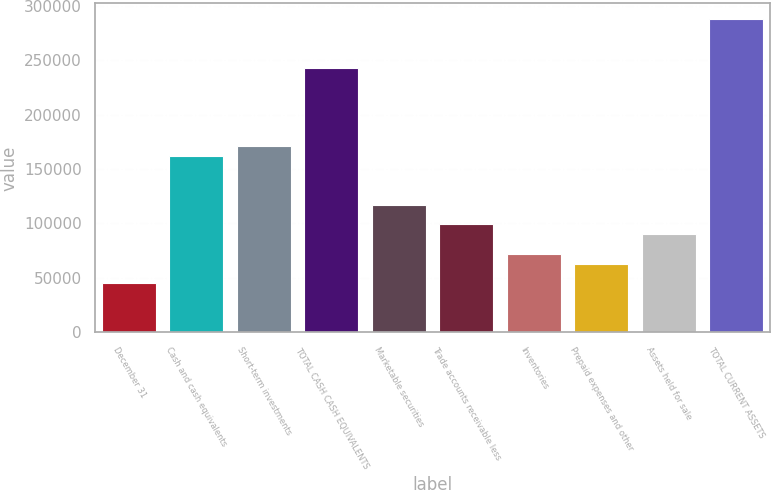<chart> <loc_0><loc_0><loc_500><loc_500><bar_chart><fcel>December 31<fcel>Cash and cash equivalents<fcel>Short-term investments<fcel>TOTAL CASH CASH EQUIVALENTS<fcel>Marketable securities<fcel>Trade accounts receivable less<fcel>Inventories<fcel>Prepaid expenses and other<fcel>Assets held for sale<fcel>TOTAL CURRENT ASSETS<nl><fcel>45151.5<fcel>161999<fcel>170988<fcel>242894<fcel>117058<fcel>99081.3<fcel>72116.4<fcel>63128.1<fcel>90093<fcel>287836<nl></chart> 